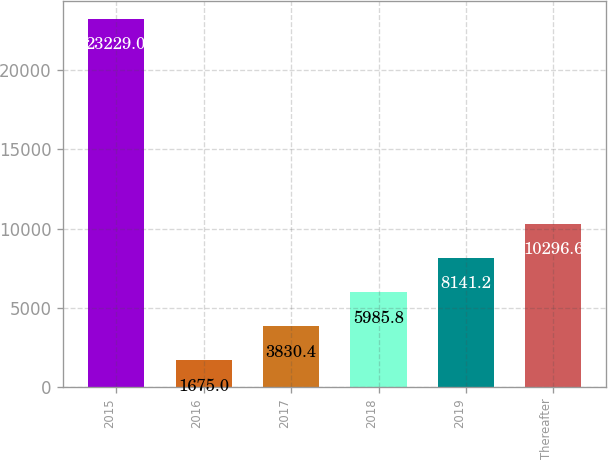Convert chart. <chart><loc_0><loc_0><loc_500><loc_500><bar_chart><fcel>2015<fcel>2016<fcel>2017<fcel>2018<fcel>2019<fcel>Thereafter<nl><fcel>23229<fcel>1675<fcel>3830.4<fcel>5985.8<fcel>8141.2<fcel>10296.6<nl></chart> 